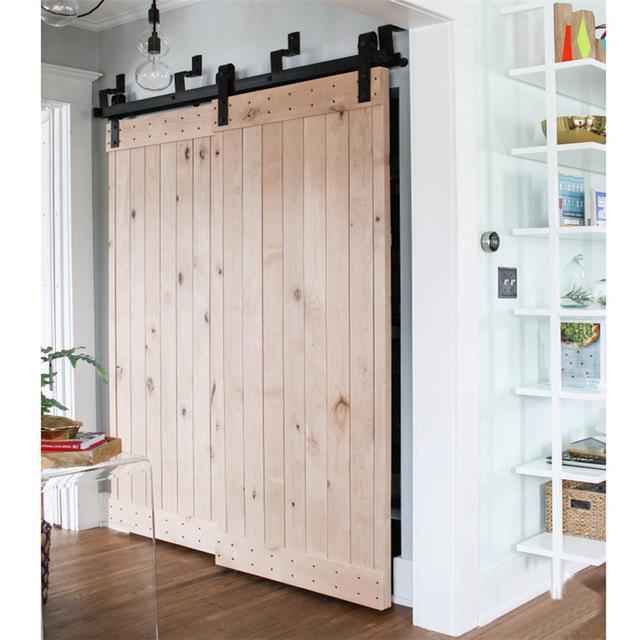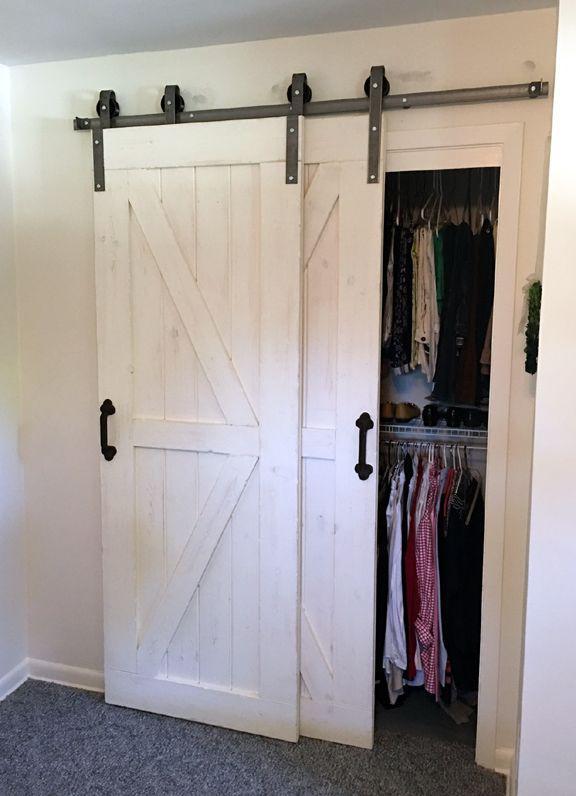The first image is the image on the left, the second image is the image on the right. Considering the images on both sides, is "There is a closet white sliding doors in one of the images." valid? Answer yes or no. Yes. The first image is the image on the left, the second image is the image on the right. Analyze the images presented: Is the assertion "A white sliding closet door on overhead bar is standing open." valid? Answer yes or no. Yes. 